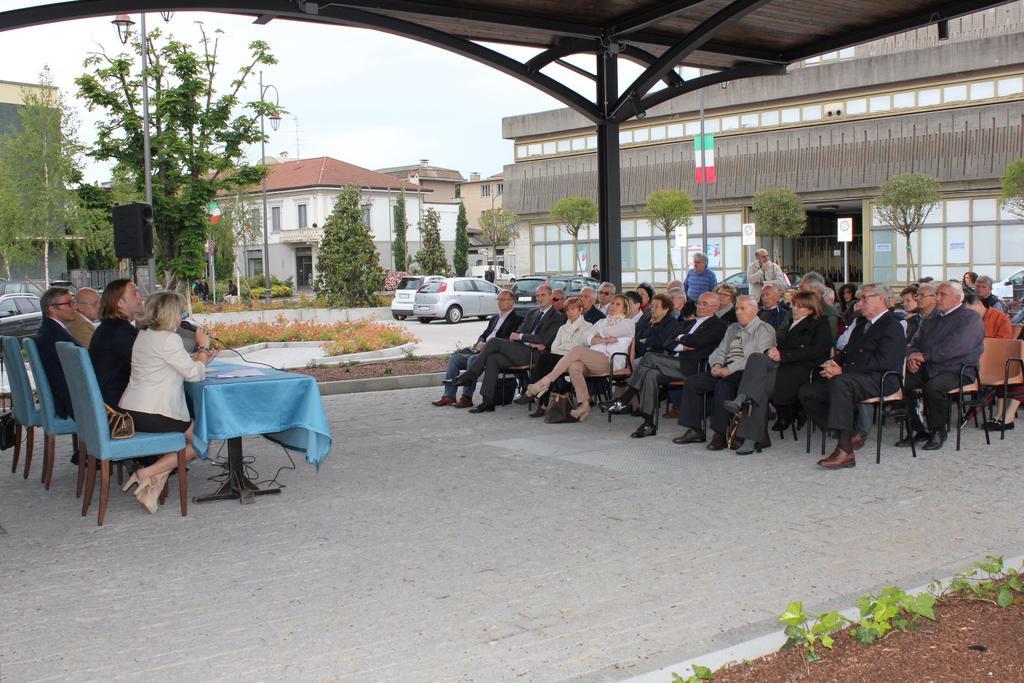In one or two sentences, can you explain what this image depicts? In this picture we can see some people are sitting on chairs, on the left side there is a table, a woman on the left side is holding a microphone, in the background there are buildings, trees, plants, pole and cars, on the right side there are two persons standing, we can also see boards on the right side, there is the sky at the top of the picture. 